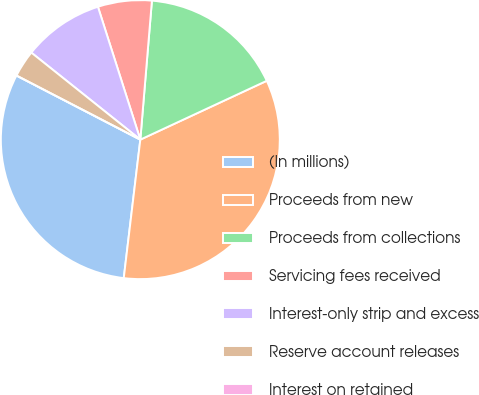<chart> <loc_0><loc_0><loc_500><loc_500><pie_chart><fcel>(In millions)<fcel>Proceeds from new<fcel>Proceeds from collections<fcel>Servicing fees received<fcel>Interest-only strip and excess<fcel>Reserve account releases<fcel>Interest on retained<nl><fcel>30.7%<fcel>33.82%<fcel>16.74%<fcel>6.24%<fcel>9.36%<fcel>3.12%<fcel>0.0%<nl></chart> 